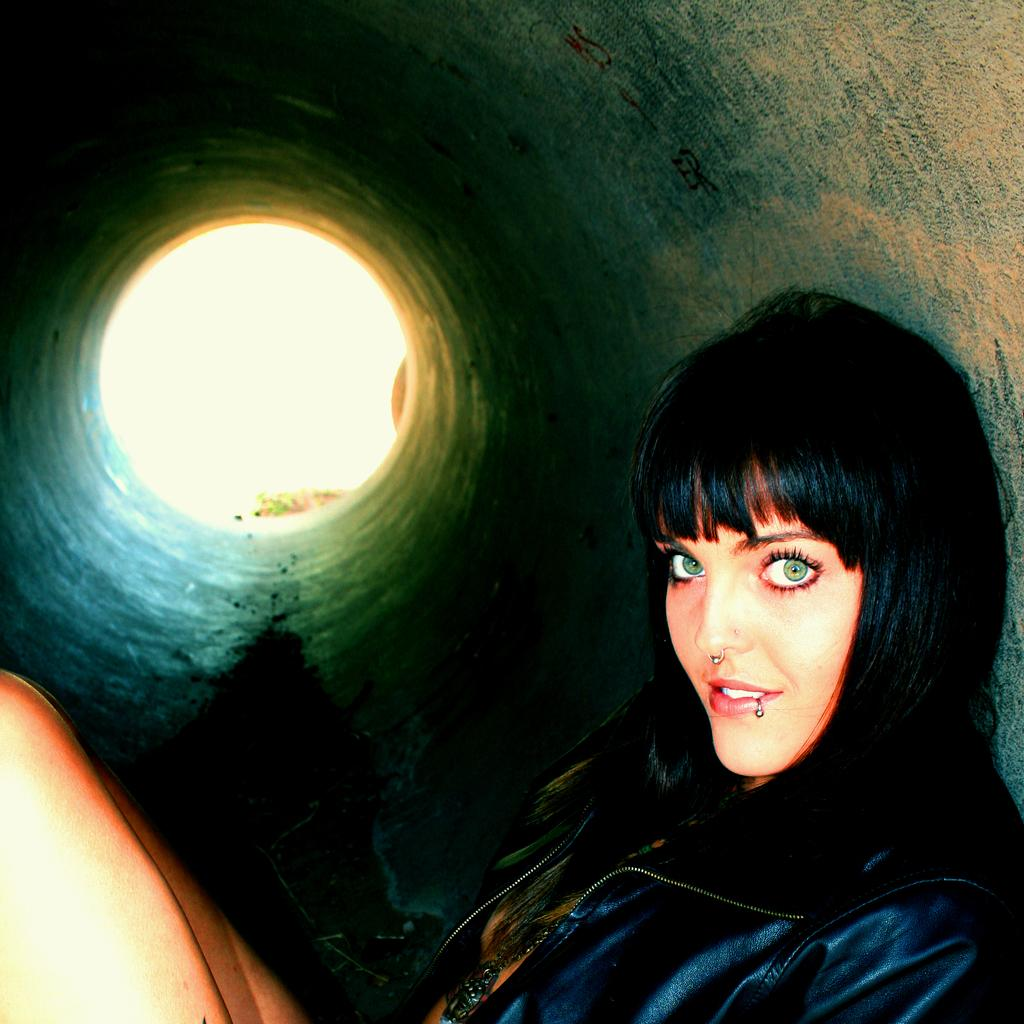What is the main subject of the image? The main subject of the image is a lady. Where is the lady located in the image? The lady is sitting inside a pipe tunnel. What type of accessory is the lady wearing on her face? The lady has a nose ring. What type of drink is the lady holding in the image? There is no drink visible in the image. What type of creatures can be seen crawling on the ground in the image? There are no creatures visible in the image, let alone crawling on the ground. 